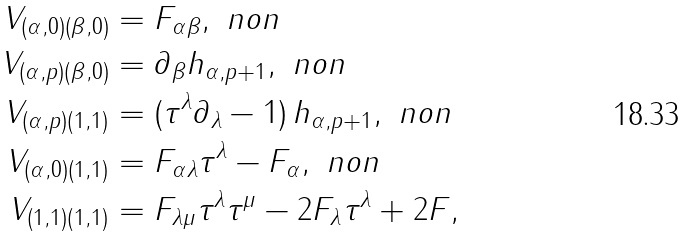<formula> <loc_0><loc_0><loc_500><loc_500>V _ { ( \alpha , 0 ) ( \beta , 0 ) } & = F _ { \alpha \beta } , \ n o n \\ V _ { ( \alpha , p ) ( \beta , 0 ) } & = \partial _ { \beta } h _ { \alpha , p + 1 } , \ n o n \\ V _ { ( \alpha , p ) ( 1 , 1 ) } & = ( \tau ^ { \lambda } \partial _ { \lambda } - 1 ) \, h _ { \alpha , p + 1 } , \ n o n \\ V _ { ( \alpha , 0 ) ( 1 , 1 ) } & = F _ { \alpha \lambda } \tau ^ { \lambda } - F _ { \alpha } , \ n o n \\ V _ { ( 1 , 1 ) ( 1 , 1 ) } & = F _ { \lambda \mu } \tau ^ { \lambda } \tau ^ { \mu } - 2 F _ { \lambda } \tau ^ { \lambda } + 2 F ,</formula> 